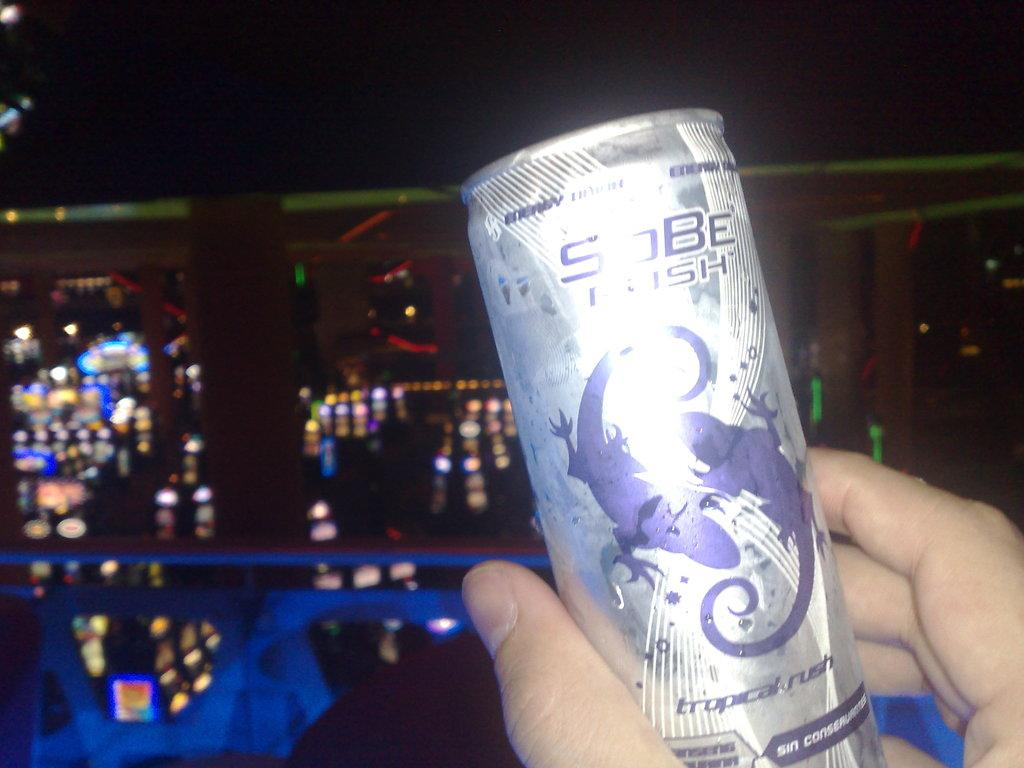<image>
Present a compact description of the photo's key features. A person holds a can of SoBe tropical rush in front of a dark background. 